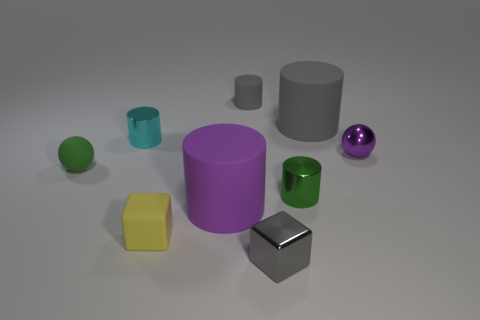Subtract all small rubber cylinders. How many cylinders are left? 4 Subtract all purple cylinders. How many cylinders are left? 4 Subtract 1 balls. How many balls are left? 1 Subtract all gray cylinders. Subtract all yellow cubes. How many cylinders are left? 3 Subtract all purple blocks. How many purple cylinders are left? 1 Subtract 2 gray cylinders. How many objects are left? 7 Subtract all blocks. How many objects are left? 7 Subtract all tiny green matte things. Subtract all purple metal balls. How many objects are left? 7 Add 3 big gray things. How many big gray things are left? 4 Add 8 blue rubber things. How many blue rubber things exist? 8 